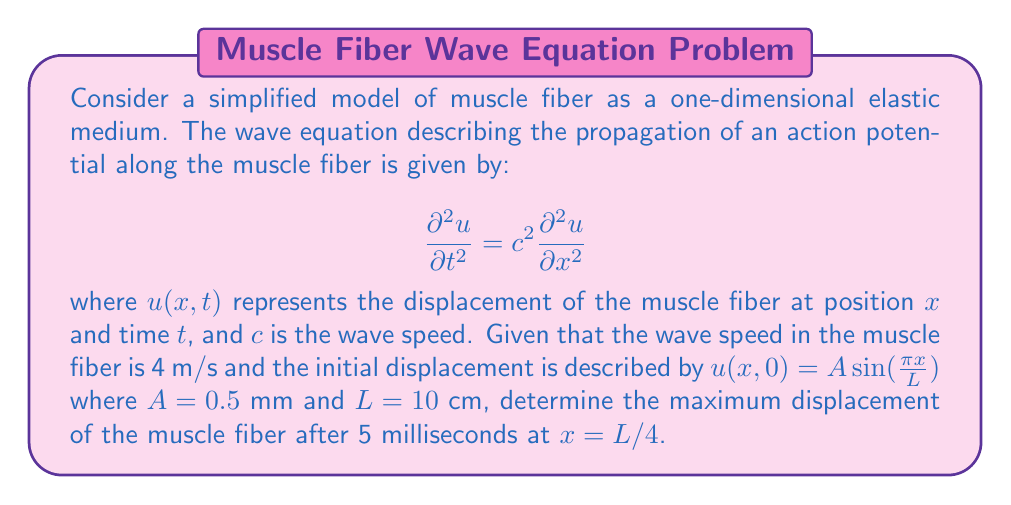Show me your answer to this math problem. To solve this problem, we need to use the general solution of the wave equation and apply the given initial conditions. The general solution for the wave equation in one dimension is:

$$u(x,t) = f(x-ct) + g(x+ct)$$

where $f$ and $g$ are arbitrary functions determined by the initial conditions.

Given the initial displacement:

$$u(x,0) = A \sin(\frac{\pi x}{L})$$

We can write the solution as:

$$u(x,t) = \frac{A}{2}\left[\sin\left(\frac{\pi(x-ct)}{L}\right) + \sin\left(\frac{\pi(x+ct)}{L}\right)\right]$$

Using trigonometric identities, this can be simplified to:

$$u(x,t) = A \sin\left(\frac{\pi x}{L}\right) \cos\left(\frac{\pi ct}{L}\right)$$

Now, we can substitute the given values:
- $A = 0.5$ mm = $5 \times 10^{-4}$ m
- $L = 10$ cm = $0.1$ m
- $c = 4$ m/s
- $t = 5$ ms = $5 \times 10^{-3}$ s
- $x = L/4 = 0.025$ m

$$u(0.025, 0.005) = (5 \times 10^{-4}) \sin\left(\frac{\pi (0.025)}{0.1}\right) \cos\left(\frac{\pi (4)(0.005)}{0.1}\right)$$

$$u(0.025, 0.005) = (5 \times 10^{-4}) \sin\left(\frac{\pi}{4}\right) \cos\left(\frac{\pi}{5}\right)$$

$$u(0.025, 0.005) = (5 \times 10^{-4}) (0.7071) (0.8090)$$

$$u(0.025, 0.005) = 2.859 \times 10^{-4} \text{ m} = 0.2859 \text{ mm}$$
Answer: The maximum displacement of the muscle fiber after 5 milliseconds at $x = L/4$ is approximately 0.2859 mm. 